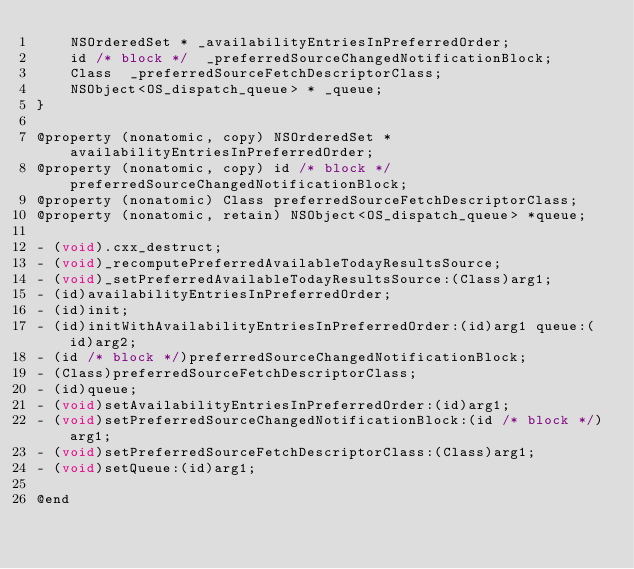Convert code to text. <code><loc_0><loc_0><loc_500><loc_500><_C_>    NSOrderedSet * _availabilityEntriesInPreferredOrder;
    id /* block */  _preferredSourceChangedNotificationBlock;
    Class  _preferredSourceFetchDescriptorClass;
    NSObject<OS_dispatch_queue> * _queue;
}

@property (nonatomic, copy) NSOrderedSet *availabilityEntriesInPreferredOrder;
@property (nonatomic, copy) id /* block */ preferredSourceChangedNotificationBlock;
@property (nonatomic) Class preferredSourceFetchDescriptorClass;
@property (nonatomic, retain) NSObject<OS_dispatch_queue> *queue;

- (void).cxx_destruct;
- (void)_recomputePreferredAvailableTodayResultsSource;
- (void)_setPreferredAvailableTodayResultsSource:(Class)arg1;
- (id)availabilityEntriesInPreferredOrder;
- (id)init;
- (id)initWithAvailabilityEntriesInPreferredOrder:(id)arg1 queue:(id)arg2;
- (id /* block */)preferredSourceChangedNotificationBlock;
- (Class)preferredSourceFetchDescriptorClass;
- (id)queue;
- (void)setAvailabilityEntriesInPreferredOrder:(id)arg1;
- (void)setPreferredSourceChangedNotificationBlock:(id /* block */)arg1;
- (void)setPreferredSourceFetchDescriptorClass:(Class)arg1;
- (void)setQueue:(id)arg1;

@end
</code> 